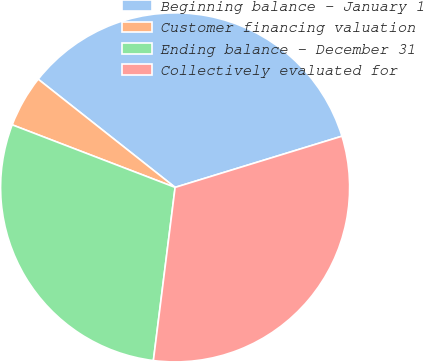<chart> <loc_0><loc_0><loc_500><loc_500><pie_chart><fcel>Beginning balance - January 1<fcel>Customer financing valuation<fcel>Ending balance - December 31<fcel>Collectively evaluated for<nl><fcel>34.62%<fcel>4.81%<fcel>28.85%<fcel>31.73%<nl></chart> 